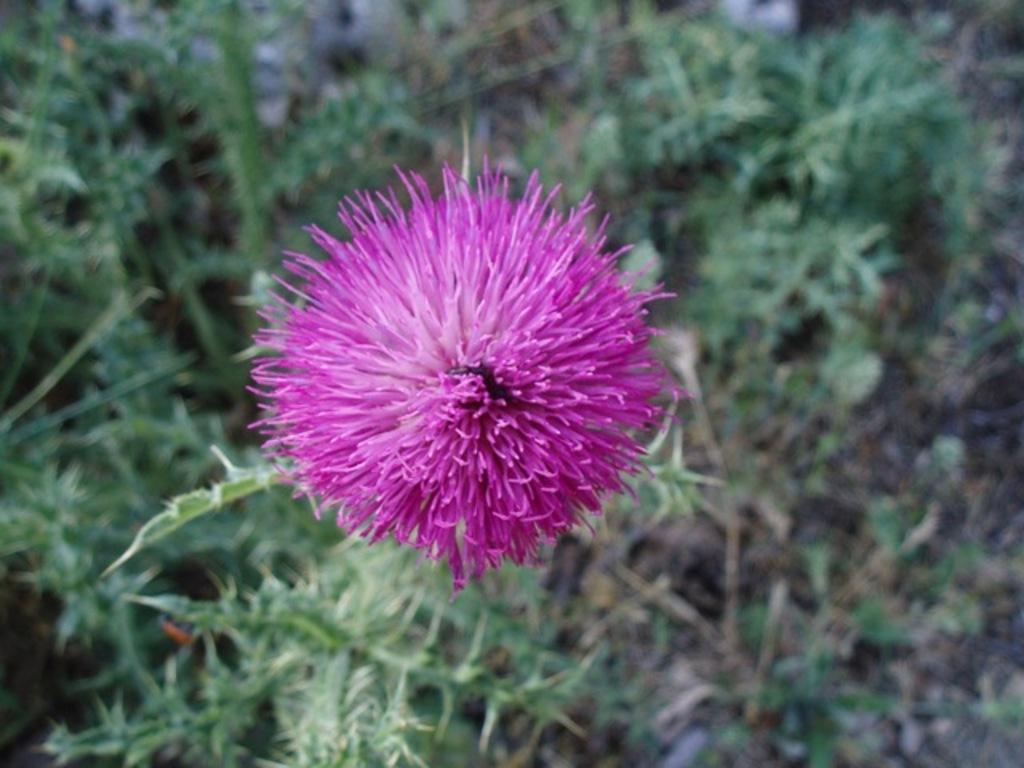Can you describe this image briefly? In this image there is a beautiful flower, in the background it is blurred. 